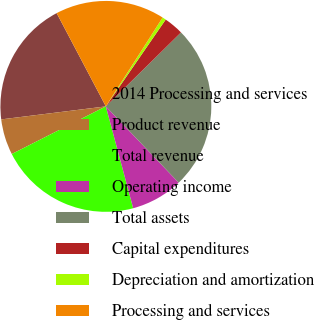Convert chart. <chart><loc_0><loc_0><loc_500><loc_500><pie_chart><fcel>2014 Processing and services<fcel>Product revenue<fcel>Total revenue<fcel>Operating income<fcel>Total assets<fcel>Capital expenditures<fcel>Depreciation and amortization<fcel>Processing and services<nl><fcel>19.24%<fcel>5.49%<fcel>21.71%<fcel>7.96%<fcel>25.24%<fcel>3.02%<fcel>0.56%<fcel>16.77%<nl></chart> 